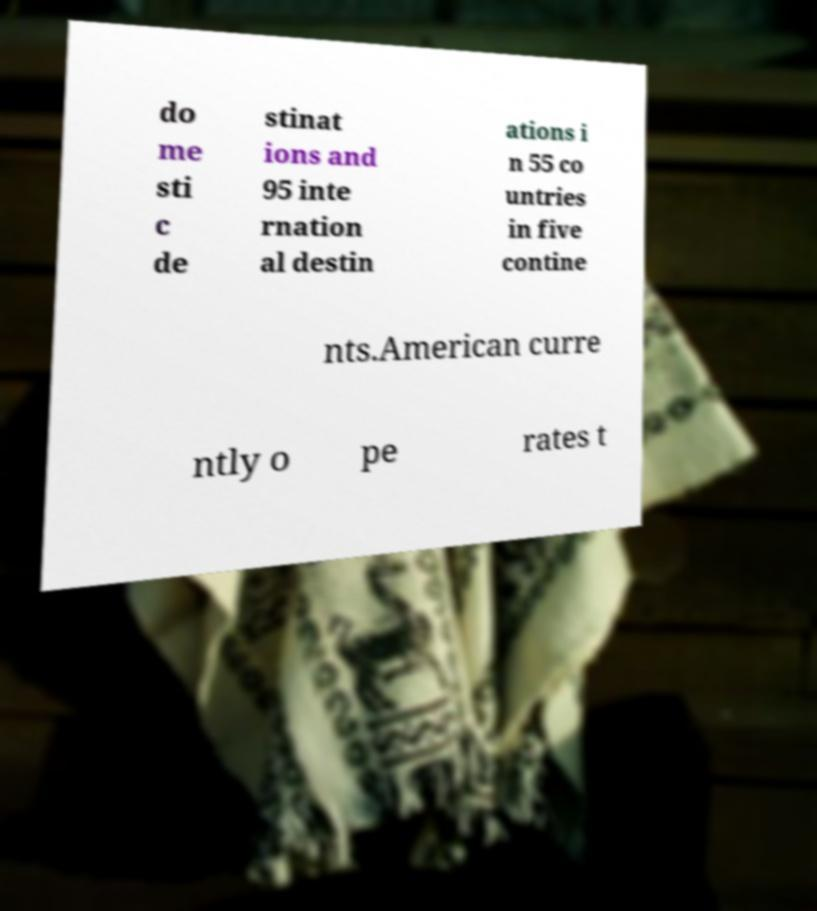What messages or text are displayed in this image? I need them in a readable, typed format. do me sti c de stinat ions and 95 inte rnation al destin ations i n 55 co untries in five contine nts.American curre ntly o pe rates t 